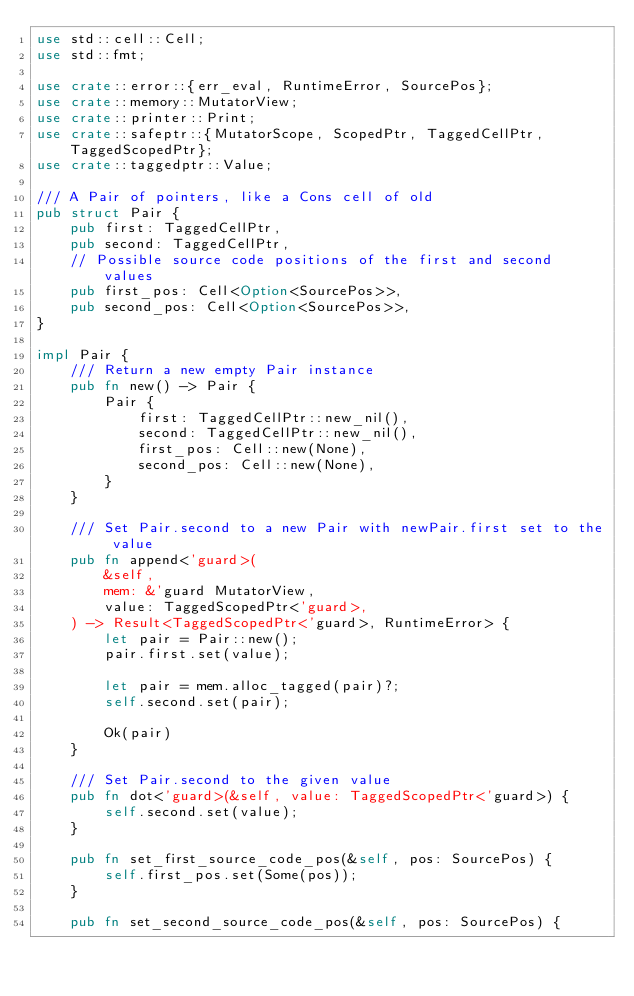<code> <loc_0><loc_0><loc_500><loc_500><_Rust_>use std::cell::Cell;
use std::fmt;

use crate::error::{err_eval, RuntimeError, SourcePos};
use crate::memory::MutatorView;
use crate::printer::Print;
use crate::safeptr::{MutatorScope, ScopedPtr, TaggedCellPtr, TaggedScopedPtr};
use crate::taggedptr::Value;

/// A Pair of pointers, like a Cons cell of old
pub struct Pair {
    pub first: TaggedCellPtr,
    pub second: TaggedCellPtr,
    // Possible source code positions of the first and second values
    pub first_pos: Cell<Option<SourcePos>>,
    pub second_pos: Cell<Option<SourcePos>>,
}

impl Pair {
    /// Return a new empty Pair instance
    pub fn new() -> Pair {
        Pair {
            first: TaggedCellPtr::new_nil(),
            second: TaggedCellPtr::new_nil(),
            first_pos: Cell::new(None),
            second_pos: Cell::new(None),
        }
    }

    /// Set Pair.second to a new Pair with newPair.first set to the value
    pub fn append<'guard>(
        &self,
        mem: &'guard MutatorView,
        value: TaggedScopedPtr<'guard>,
    ) -> Result<TaggedScopedPtr<'guard>, RuntimeError> {
        let pair = Pair::new();
        pair.first.set(value);

        let pair = mem.alloc_tagged(pair)?;
        self.second.set(pair);

        Ok(pair)
    }

    /// Set Pair.second to the given value
    pub fn dot<'guard>(&self, value: TaggedScopedPtr<'guard>) {
        self.second.set(value);
    }

    pub fn set_first_source_code_pos(&self, pos: SourcePos) {
        self.first_pos.set(Some(pos));
    }

    pub fn set_second_source_code_pos(&self, pos: SourcePos) {</code> 